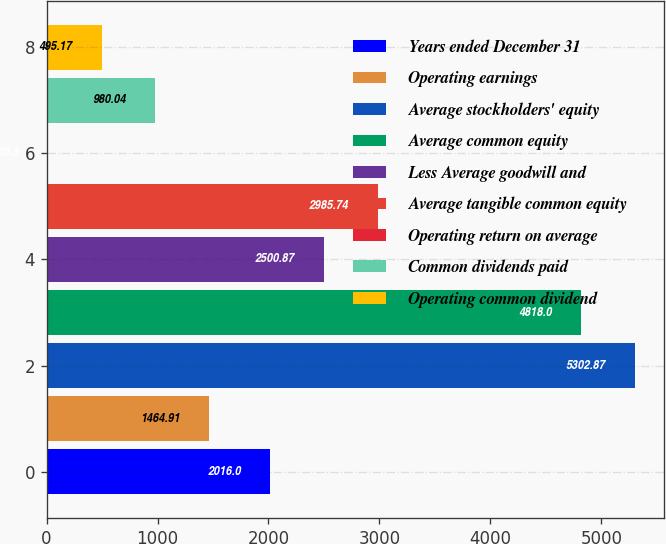Convert chart to OTSL. <chart><loc_0><loc_0><loc_500><loc_500><bar_chart><fcel>Years ended December 31<fcel>Operating earnings<fcel>Average stockholders' equity<fcel>Average common equity<fcel>Less Average goodwill and<fcel>Average tangible common equity<fcel>Operating return on average<fcel>Common dividends paid<fcel>Operating common dividend<nl><fcel>2016<fcel>1464.91<fcel>5302.87<fcel>4818<fcel>2500.87<fcel>2985.74<fcel>10.3<fcel>980.04<fcel>495.17<nl></chart> 